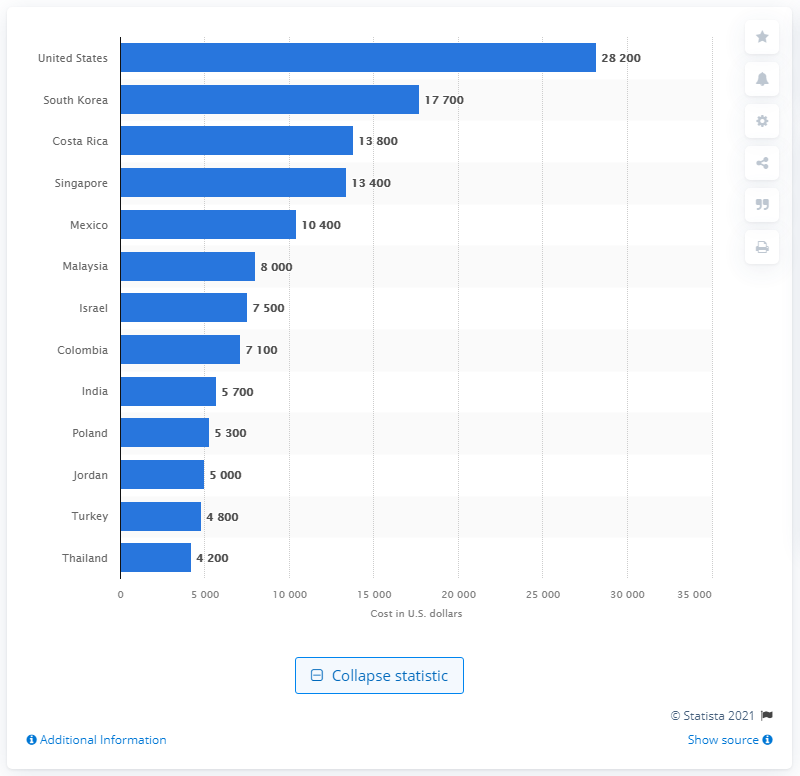Highlight a few significant elements in this photo. According to recent data, an angioplasty procedure in Costa Rica costs significantly less than the same procedure in the United States, with a cost of less than half of the US dollar. 